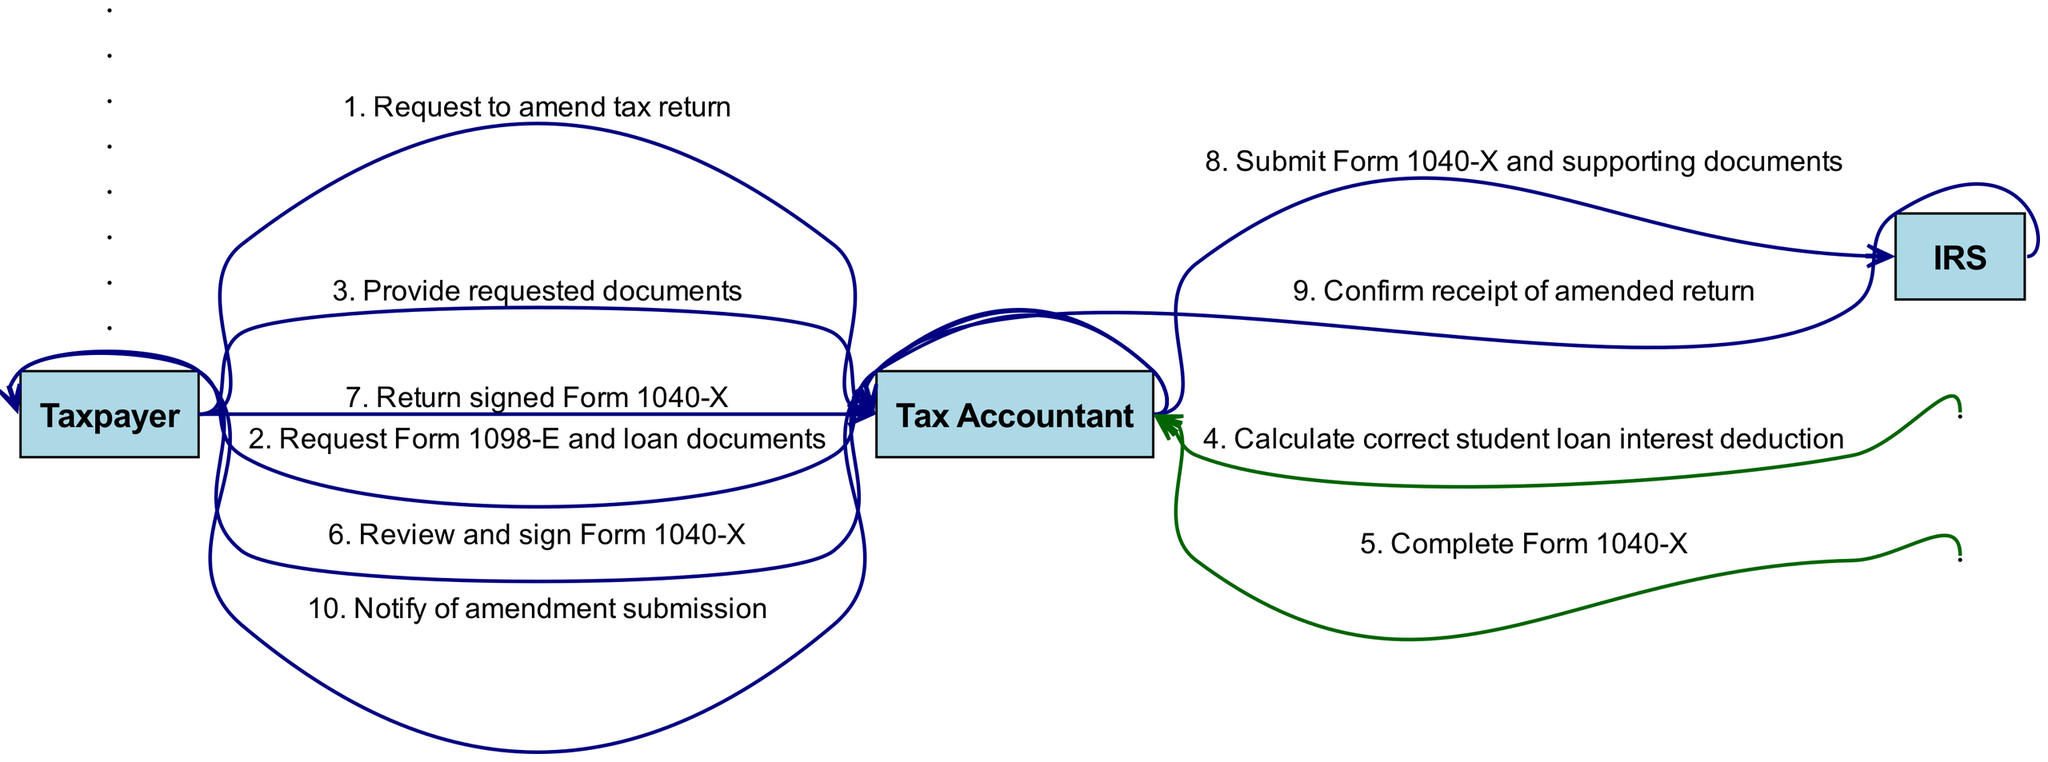What is the first action taken by the Taxpayer? The first action taken by the Taxpayer in the sequence is to request to amend the tax return. This is shown as the first message flowing from the Taxpayer to the Tax Accountant.
Answer: Request to amend tax return How many times does the Tax Accountant act on their own? The Tax Accountant acts on their own in three instances where they are both the sender and receiver of messages. These actions include calculating the correct student loan interest deduction, completing Form 1040-X, and reviewing and signing Form 1040-X.
Answer: Three Which form is involved in the amendment process? The form involved in the amendment process is Form 1040-X, which the Tax Accountant completes and the Taxpayer reviews and signs before submission to the IRS.
Answer: Form 1040-X Who confirms the receipt of the amended return? The IRS confirms the receipt of the amended return, as indicated by the response sent back to the Tax Accountant after submission.
Answer: IRS What action does the Tax Accountant take after receiving the signed Form 1040-X from the Taxpayer? After receiving the signed Form 1040-X from the Taxpayer, the Tax Accountant submits Form 1040-X along with the supporting documents to the IRS. This is shown as a message flowing from the Tax Accountant to the IRS.
Answer: Submit Form 1040-X and supporting documents What relationship is depicted between the Taxpayer and the Tax Accountant? The relationship depicted between the Taxpayer and the Tax Accountant is one of collaboration, where the Taxpayer requests assistance and provides documents, while the Tax Accountant guides the Taxpayer through the amendment process and handles the submission to the IRS.
Answer: Collaboration 